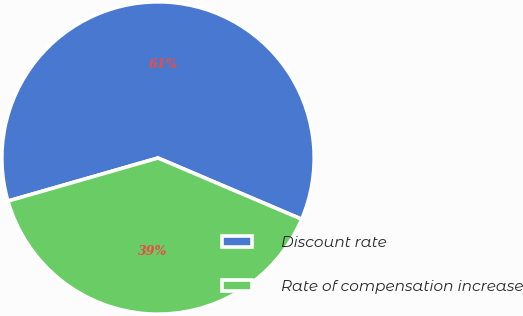Convert chart. <chart><loc_0><loc_0><loc_500><loc_500><pie_chart><fcel>Discount rate<fcel>Rate of compensation increase<nl><fcel>60.86%<fcel>39.14%<nl></chart> 